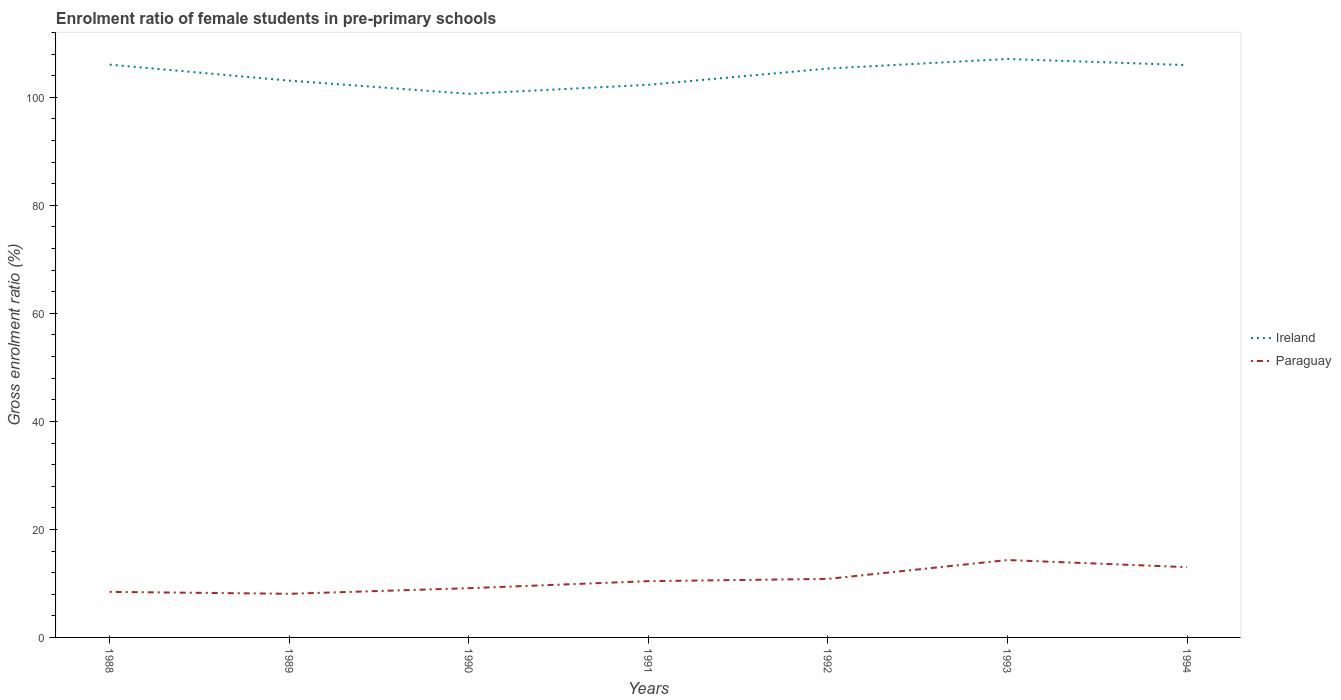How many different coloured lines are there?
Provide a succinct answer. 2. Is the number of lines equal to the number of legend labels?
Give a very brief answer. Yes. Across all years, what is the maximum enrolment ratio of female students in pre-primary schools in Paraguay?
Your answer should be compact. 8.08. In which year was the enrolment ratio of female students in pre-primary schools in Paraguay maximum?
Keep it short and to the point. 1989. What is the total enrolment ratio of female students in pre-primary schools in Ireland in the graph?
Ensure brevity in your answer.  -3.02. What is the difference between the highest and the second highest enrolment ratio of female students in pre-primary schools in Ireland?
Give a very brief answer. 6.45. What is the difference between the highest and the lowest enrolment ratio of female students in pre-primary schools in Ireland?
Give a very brief answer. 4. How many lines are there?
Your response must be concise. 2. How many years are there in the graph?
Your answer should be compact. 7. Are the values on the major ticks of Y-axis written in scientific E-notation?
Ensure brevity in your answer.  No. Does the graph contain any zero values?
Provide a succinct answer. No. Where does the legend appear in the graph?
Keep it short and to the point. Center right. How are the legend labels stacked?
Your answer should be compact. Vertical. What is the title of the graph?
Provide a succinct answer. Enrolment ratio of female students in pre-primary schools. Does "Virgin Islands" appear as one of the legend labels in the graph?
Your answer should be compact. No. What is the label or title of the X-axis?
Provide a short and direct response. Years. What is the Gross enrolment ratio (%) of Ireland in 1988?
Ensure brevity in your answer.  106.06. What is the Gross enrolment ratio (%) of Paraguay in 1988?
Give a very brief answer. 8.44. What is the Gross enrolment ratio (%) of Ireland in 1989?
Your answer should be very brief. 103.1. What is the Gross enrolment ratio (%) in Paraguay in 1989?
Provide a short and direct response. 8.08. What is the Gross enrolment ratio (%) of Ireland in 1990?
Ensure brevity in your answer.  100.66. What is the Gross enrolment ratio (%) of Paraguay in 1990?
Offer a very short reply. 9.12. What is the Gross enrolment ratio (%) in Ireland in 1991?
Ensure brevity in your answer.  102.32. What is the Gross enrolment ratio (%) of Paraguay in 1991?
Your answer should be compact. 10.42. What is the Gross enrolment ratio (%) in Ireland in 1992?
Give a very brief answer. 105.34. What is the Gross enrolment ratio (%) of Paraguay in 1992?
Your answer should be compact. 10.84. What is the Gross enrolment ratio (%) in Ireland in 1993?
Your response must be concise. 107.11. What is the Gross enrolment ratio (%) in Paraguay in 1993?
Provide a short and direct response. 14.33. What is the Gross enrolment ratio (%) of Ireland in 1994?
Your response must be concise. 105.98. What is the Gross enrolment ratio (%) of Paraguay in 1994?
Your answer should be very brief. 13.01. Across all years, what is the maximum Gross enrolment ratio (%) of Ireland?
Ensure brevity in your answer.  107.11. Across all years, what is the maximum Gross enrolment ratio (%) in Paraguay?
Make the answer very short. 14.33. Across all years, what is the minimum Gross enrolment ratio (%) in Ireland?
Keep it short and to the point. 100.66. Across all years, what is the minimum Gross enrolment ratio (%) in Paraguay?
Offer a terse response. 8.08. What is the total Gross enrolment ratio (%) of Ireland in the graph?
Your answer should be compact. 730.56. What is the total Gross enrolment ratio (%) in Paraguay in the graph?
Give a very brief answer. 74.23. What is the difference between the Gross enrolment ratio (%) of Ireland in 1988 and that in 1989?
Offer a terse response. 2.96. What is the difference between the Gross enrolment ratio (%) of Paraguay in 1988 and that in 1989?
Keep it short and to the point. 0.36. What is the difference between the Gross enrolment ratio (%) of Ireland in 1988 and that in 1990?
Ensure brevity in your answer.  5.4. What is the difference between the Gross enrolment ratio (%) of Paraguay in 1988 and that in 1990?
Ensure brevity in your answer.  -0.68. What is the difference between the Gross enrolment ratio (%) of Ireland in 1988 and that in 1991?
Offer a terse response. 3.73. What is the difference between the Gross enrolment ratio (%) in Paraguay in 1988 and that in 1991?
Your answer should be very brief. -1.98. What is the difference between the Gross enrolment ratio (%) of Ireland in 1988 and that in 1992?
Make the answer very short. 0.72. What is the difference between the Gross enrolment ratio (%) in Paraguay in 1988 and that in 1992?
Keep it short and to the point. -2.41. What is the difference between the Gross enrolment ratio (%) in Ireland in 1988 and that in 1993?
Your answer should be compact. -1.05. What is the difference between the Gross enrolment ratio (%) in Paraguay in 1988 and that in 1993?
Provide a succinct answer. -5.89. What is the difference between the Gross enrolment ratio (%) of Ireland in 1988 and that in 1994?
Ensure brevity in your answer.  0.08. What is the difference between the Gross enrolment ratio (%) in Paraguay in 1988 and that in 1994?
Offer a very short reply. -4.58. What is the difference between the Gross enrolment ratio (%) in Ireland in 1989 and that in 1990?
Make the answer very short. 2.44. What is the difference between the Gross enrolment ratio (%) of Paraguay in 1989 and that in 1990?
Your answer should be compact. -1.04. What is the difference between the Gross enrolment ratio (%) of Ireland in 1989 and that in 1991?
Offer a very short reply. 0.77. What is the difference between the Gross enrolment ratio (%) of Paraguay in 1989 and that in 1991?
Provide a short and direct response. -2.34. What is the difference between the Gross enrolment ratio (%) of Ireland in 1989 and that in 1992?
Your answer should be very brief. -2.24. What is the difference between the Gross enrolment ratio (%) in Paraguay in 1989 and that in 1992?
Make the answer very short. -2.76. What is the difference between the Gross enrolment ratio (%) of Ireland in 1989 and that in 1993?
Make the answer very short. -4.01. What is the difference between the Gross enrolment ratio (%) in Paraguay in 1989 and that in 1993?
Ensure brevity in your answer.  -6.25. What is the difference between the Gross enrolment ratio (%) of Ireland in 1989 and that in 1994?
Your response must be concise. -2.88. What is the difference between the Gross enrolment ratio (%) in Paraguay in 1989 and that in 1994?
Provide a short and direct response. -4.93. What is the difference between the Gross enrolment ratio (%) in Ireland in 1990 and that in 1991?
Ensure brevity in your answer.  -1.67. What is the difference between the Gross enrolment ratio (%) of Paraguay in 1990 and that in 1991?
Offer a terse response. -1.3. What is the difference between the Gross enrolment ratio (%) in Ireland in 1990 and that in 1992?
Give a very brief answer. -4.68. What is the difference between the Gross enrolment ratio (%) in Paraguay in 1990 and that in 1992?
Your answer should be compact. -1.72. What is the difference between the Gross enrolment ratio (%) of Ireland in 1990 and that in 1993?
Ensure brevity in your answer.  -6.45. What is the difference between the Gross enrolment ratio (%) of Paraguay in 1990 and that in 1993?
Your answer should be compact. -5.21. What is the difference between the Gross enrolment ratio (%) of Ireland in 1990 and that in 1994?
Give a very brief answer. -5.32. What is the difference between the Gross enrolment ratio (%) of Paraguay in 1990 and that in 1994?
Ensure brevity in your answer.  -3.89. What is the difference between the Gross enrolment ratio (%) of Ireland in 1991 and that in 1992?
Provide a short and direct response. -3.02. What is the difference between the Gross enrolment ratio (%) of Paraguay in 1991 and that in 1992?
Ensure brevity in your answer.  -0.42. What is the difference between the Gross enrolment ratio (%) of Ireland in 1991 and that in 1993?
Your response must be concise. -4.78. What is the difference between the Gross enrolment ratio (%) in Paraguay in 1991 and that in 1993?
Ensure brevity in your answer.  -3.91. What is the difference between the Gross enrolment ratio (%) in Ireland in 1991 and that in 1994?
Your answer should be very brief. -3.65. What is the difference between the Gross enrolment ratio (%) of Paraguay in 1991 and that in 1994?
Provide a short and direct response. -2.59. What is the difference between the Gross enrolment ratio (%) in Ireland in 1992 and that in 1993?
Offer a terse response. -1.76. What is the difference between the Gross enrolment ratio (%) of Paraguay in 1992 and that in 1993?
Provide a short and direct response. -3.49. What is the difference between the Gross enrolment ratio (%) of Ireland in 1992 and that in 1994?
Keep it short and to the point. -0.64. What is the difference between the Gross enrolment ratio (%) in Paraguay in 1992 and that in 1994?
Give a very brief answer. -2.17. What is the difference between the Gross enrolment ratio (%) in Ireland in 1993 and that in 1994?
Keep it short and to the point. 1.13. What is the difference between the Gross enrolment ratio (%) in Paraguay in 1993 and that in 1994?
Your response must be concise. 1.32. What is the difference between the Gross enrolment ratio (%) of Ireland in 1988 and the Gross enrolment ratio (%) of Paraguay in 1989?
Provide a short and direct response. 97.98. What is the difference between the Gross enrolment ratio (%) in Ireland in 1988 and the Gross enrolment ratio (%) in Paraguay in 1990?
Ensure brevity in your answer.  96.94. What is the difference between the Gross enrolment ratio (%) of Ireland in 1988 and the Gross enrolment ratio (%) of Paraguay in 1991?
Keep it short and to the point. 95.64. What is the difference between the Gross enrolment ratio (%) in Ireland in 1988 and the Gross enrolment ratio (%) in Paraguay in 1992?
Provide a succinct answer. 95.22. What is the difference between the Gross enrolment ratio (%) of Ireland in 1988 and the Gross enrolment ratio (%) of Paraguay in 1993?
Keep it short and to the point. 91.73. What is the difference between the Gross enrolment ratio (%) in Ireland in 1988 and the Gross enrolment ratio (%) in Paraguay in 1994?
Ensure brevity in your answer.  93.05. What is the difference between the Gross enrolment ratio (%) of Ireland in 1989 and the Gross enrolment ratio (%) of Paraguay in 1990?
Offer a very short reply. 93.98. What is the difference between the Gross enrolment ratio (%) in Ireland in 1989 and the Gross enrolment ratio (%) in Paraguay in 1991?
Your answer should be compact. 92.68. What is the difference between the Gross enrolment ratio (%) in Ireland in 1989 and the Gross enrolment ratio (%) in Paraguay in 1992?
Your answer should be compact. 92.26. What is the difference between the Gross enrolment ratio (%) in Ireland in 1989 and the Gross enrolment ratio (%) in Paraguay in 1993?
Give a very brief answer. 88.77. What is the difference between the Gross enrolment ratio (%) in Ireland in 1989 and the Gross enrolment ratio (%) in Paraguay in 1994?
Give a very brief answer. 90.09. What is the difference between the Gross enrolment ratio (%) of Ireland in 1990 and the Gross enrolment ratio (%) of Paraguay in 1991?
Your response must be concise. 90.24. What is the difference between the Gross enrolment ratio (%) of Ireland in 1990 and the Gross enrolment ratio (%) of Paraguay in 1992?
Keep it short and to the point. 89.82. What is the difference between the Gross enrolment ratio (%) in Ireland in 1990 and the Gross enrolment ratio (%) in Paraguay in 1993?
Your answer should be compact. 86.33. What is the difference between the Gross enrolment ratio (%) of Ireland in 1990 and the Gross enrolment ratio (%) of Paraguay in 1994?
Your answer should be very brief. 87.65. What is the difference between the Gross enrolment ratio (%) in Ireland in 1991 and the Gross enrolment ratio (%) in Paraguay in 1992?
Give a very brief answer. 91.48. What is the difference between the Gross enrolment ratio (%) in Ireland in 1991 and the Gross enrolment ratio (%) in Paraguay in 1993?
Provide a succinct answer. 87.99. What is the difference between the Gross enrolment ratio (%) in Ireland in 1991 and the Gross enrolment ratio (%) in Paraguay in 1994?
Ensure brevity in your answer.  89.31. What is the difference between the Gross enrolment ratio (%) of Ireland in 1992 and the Gross enrolment ratio (%) of Paraguay in 1993?
Offer a terse response. 91.01. What is the difference between the Gross enrolment ratio (%) in Ireland in 1992 and the Gross enrolment ratio (%) in Paraguay in 1994?
Provide a succinct answer. 92.33. What is the difference between the Gross enrolment ratio (%) of Ireland in 1993 and the Gross enrolment ratio (%) of Paraguay in 1994?
Your response must be concise. 94.09. What is the average Gross enrolment ratio (%) of Ireland per year?
Provide a succinct answer. 104.37. What is the average Gross enrolment ratio (%) in Paraguay per year?
Provide a succinct answer. 10.6. In the year 1988, what is the difference between the Gross enrolment ratio (%) of Ireland and Gross enrolment ratio (%) of Paraguay?
Give a very brief answer. 97.62. In the year 1989, what is the difference between the Gross enrolment ratio (%) of Ireland and Gross enrolment ratio (%) of Paraguay?
Provide a succinct answer. 95.02. In the year 1990, what is the difference between the Gross enrolment ratio (%) of Ireland and Gross enrolment ratio (%) of Paraguay?
Provide a short and direct response. 91.54. In the year 1991, what is the difference between the Gross enrolment ratio (%) of Ireland and Gross enrolment ratio (%) of Paraguay?
Your answer should be very brief. 91.91. In the year 1992, what is the difference between the Gross enrolment ratio (%) of Ireland and Gross enrolment ratio (%) of Paraguay?
Give a very brief answer. 94.5. In the year 1993, what is the difference between the Gross enrolment ratio (%) in Ireland and Gross enrolment ratio (%) in Paraguay?
Give a very brief answer. 92.78. In the year 1994, what is the difference between the Gross enrolment ratio (%) in Ireland and Gross enrolment ratio (%) in Paraguay?
Your answer should be very brief. 92.97. What is the ratio of the Gross enrolment ratio (%) of Ireland in 1988 to that in 1989?
Keep it short and to the point. 1.03. What is the ratio of the Gross enrolment ratio (%) in Paraguay in 1988 to that in 1989?
Give a very brief answer. 1.04. What is the ratio of the Gross enrolment ratio (%) of Ireland in 1988 to that in 1990?
Your answer should be very brief. 1.05. What is the ratio of the Gross enrolment ratio (%) in Paraguay in 1988 to that in 1990?
Provide a succinct answer. 0.93. What is the ratio of the Gross enrolment ratio (%) of Ireland in 1988 to that in 1991?
Offer a very short reply. 1.04. What is the ratio of the Gross enrolment ratio (%) in Paraguay in 1988 to that in 1991?
Offer a very short reply. 0.81. What is the ratio of the Gross enrolment ratio (%) of Ireland in 1988 to that in 1992?
Provide a short and direct response. 1.01. What is the ratio of the Gross enrolment ratio (%) in Paraguay in 1988 to that in 1992?
Provide a succinct answer. 0.78. What is the ratio of the Gross enrolment ratio (%) in Ireland in 1988 to that in 1993?
Make the answer very short. 0.99. What is the ratio of the Gross enrolment ratio (%) of Paraguay in 1988 to that in 1993?
Give a very brief answer. 0.59. What is the ratio of the Gross enrolment ratio (%) of Ireland in 1988 to that in 1994?
Provide a succinct answer. 1. What is the ratio of the Gross enrolment ratio (%) of Paraguay in 1988 to that in 1994?
Your response must be concise. 0.65. What is the ratio of the Gross enrolment ratio (%) in Ireland in 1989 to that in 1990?
Provide a short and direct response. 1.02. What is the ratio of the Gross enrolment ratio (%) in Paraguay in 1989 to that in 1990?
Provide a succinct answer. 0.89. What is the ratio of the Gross enrolment ratio (%) in Ireland in 1989 to that in 1991?
Give a very brief answer. 1.01. What is the ratio of the Gross enrolment ratio (%) in Paraguay in 1989 to that in 1991?
Offer a very short reply. 0.78. What is the ratio of the Gross enrolment ratio (%) in Ireland in 1989 to that in 1992?
Give a very brief answer. 0.98. What is the ratio of the Gross enrolment ratio (%) of Paraguay in 1989 to that in 1992?
Offer a terse response. 0.75. What is the ratio of the Gross enrolment ratio (%) in Ireland in 1989 to that in 1993?
Offer a very short reply. 0.96. What is the ratio of the Gross enrolment ratio (%) in Paraguay in 1989 to that in 1993?
Your answer should be very brief. 0.56. What is the ratio of the Gross enrolment ratio (%) in Ireland in 1989 to that in 1994?
Ensure brevity in your answer.  0.97. What is the ratio of the Gross enrolment ratio (%) of Paraguay in 1989 to that in 1994?
Keep it short and to the point. 0.62. What is the ratio of the Gross enrolment ratio (%) in Ireland in 1990 to that in 1991?
Your answer should be very brief. 0.98. What is the ratio of the Gross enrolment ratio (%) in Paraguay in 1990 to that in 1991?
Offer a terse response. 0.88. What is the ratio of the Gross enrolment ratio (%) in Ireland in 1990 to that in 1992?
Offer a terse response. 0.96. What is the ratio of the Gross enrolment ratio (%) of Paraguay in 1990 to that in 1992?
Keep it short and to the point. 0.84. What is the ratio of the Gross enrolment ratio (%) of Ireland in 1990 to that in 1993?
Your response must be concise. 0.94. What is the ratio of the Gross enrolment ratio (%) of Paraguay in 1990 to that in 1993?
Make the answer very short. 0.64. What is the ratio of the Gross enrolment ratio (%) of Ireland in 1990 to that in 1994?
Your response must be concise. 0.95. What is the ratio of the Gross enrolment ratio (%) of Paraguay in 1990 to that in 1994?
Offer a very short reply. 0.7. What is the ratio of the Gross enrolment ratio (%) of Ireland in 1991 to that in 1992?
Provide a succinct answer. 0.97. What is the ratio of the Gross enrolment ratio (%) of Paraguay in 1991 to that in 1992?
Offer a very short reply. 0.96. What is the ratio of the Gross enrolment ratio (%) of Ireland in 1991 to that in 1993?
Provide a short and direct response. 0.96. What is the ratio of the Gross enrolment ratio (%) in Paraguay in 1991 to that in 1993?
Offer a terse response. 0.73. What is the ratio of the Gross enrolment ratio (%) in Ireland in 1991 to that in 1994?
Ensure brevity in your answer.  0.97. What is the ratio of the Gross enrolment ratio (%) of Paraguay in 1991 to that in 1994?
Provide a succinct answer. 0.8. What is the ratio of the Gross enrolment ratio (%) in Ireland in 1992 to that in 1993?
Offer a very short reply. 0.98. What is the ratio of the Gross enrolment ratio (%) of Paraguay in 1992 to that in 1993?
Provide a succinct answer. 0.76. What is the ratio of the Gross enrolment ratio (%) of Ireland in 1992 to that in 1994?
Provide a short and direct response. 0.99. What is the ratio of the Gross enrolment ratio (%) in Paraguay in 1992 to that in 1994?
Ensure brevity in your answer.  0.83. What is the ratio of the Gross enrolment ratio (%) in Ireland in 1993 to that in 1994?
Provide a succinct answer. 1.01. What is the ratio of the Gross enrolment ratio (%) of Paraguay in 1993 to that in 1994?
Your answer should be very brief. 1.1. What is the difference between the highest and the second highest Gross enrolment ratio (%) of Ireland?
Make the answer very short. 1.05. What is the difference between the highest and the second highest Gross enrolment ratio (%) in Paraguay?
Ensure brevity in your answer.  1.32. What is the difference between the highest and the lowest Gross enrolment ratio (%) of Ireland?
Keep it short and to the point. 6.45. What is the difference between the highest and the lowest Gross enrolment ratio (%) in Paraguay?
Offer a terse response. 6.25. 